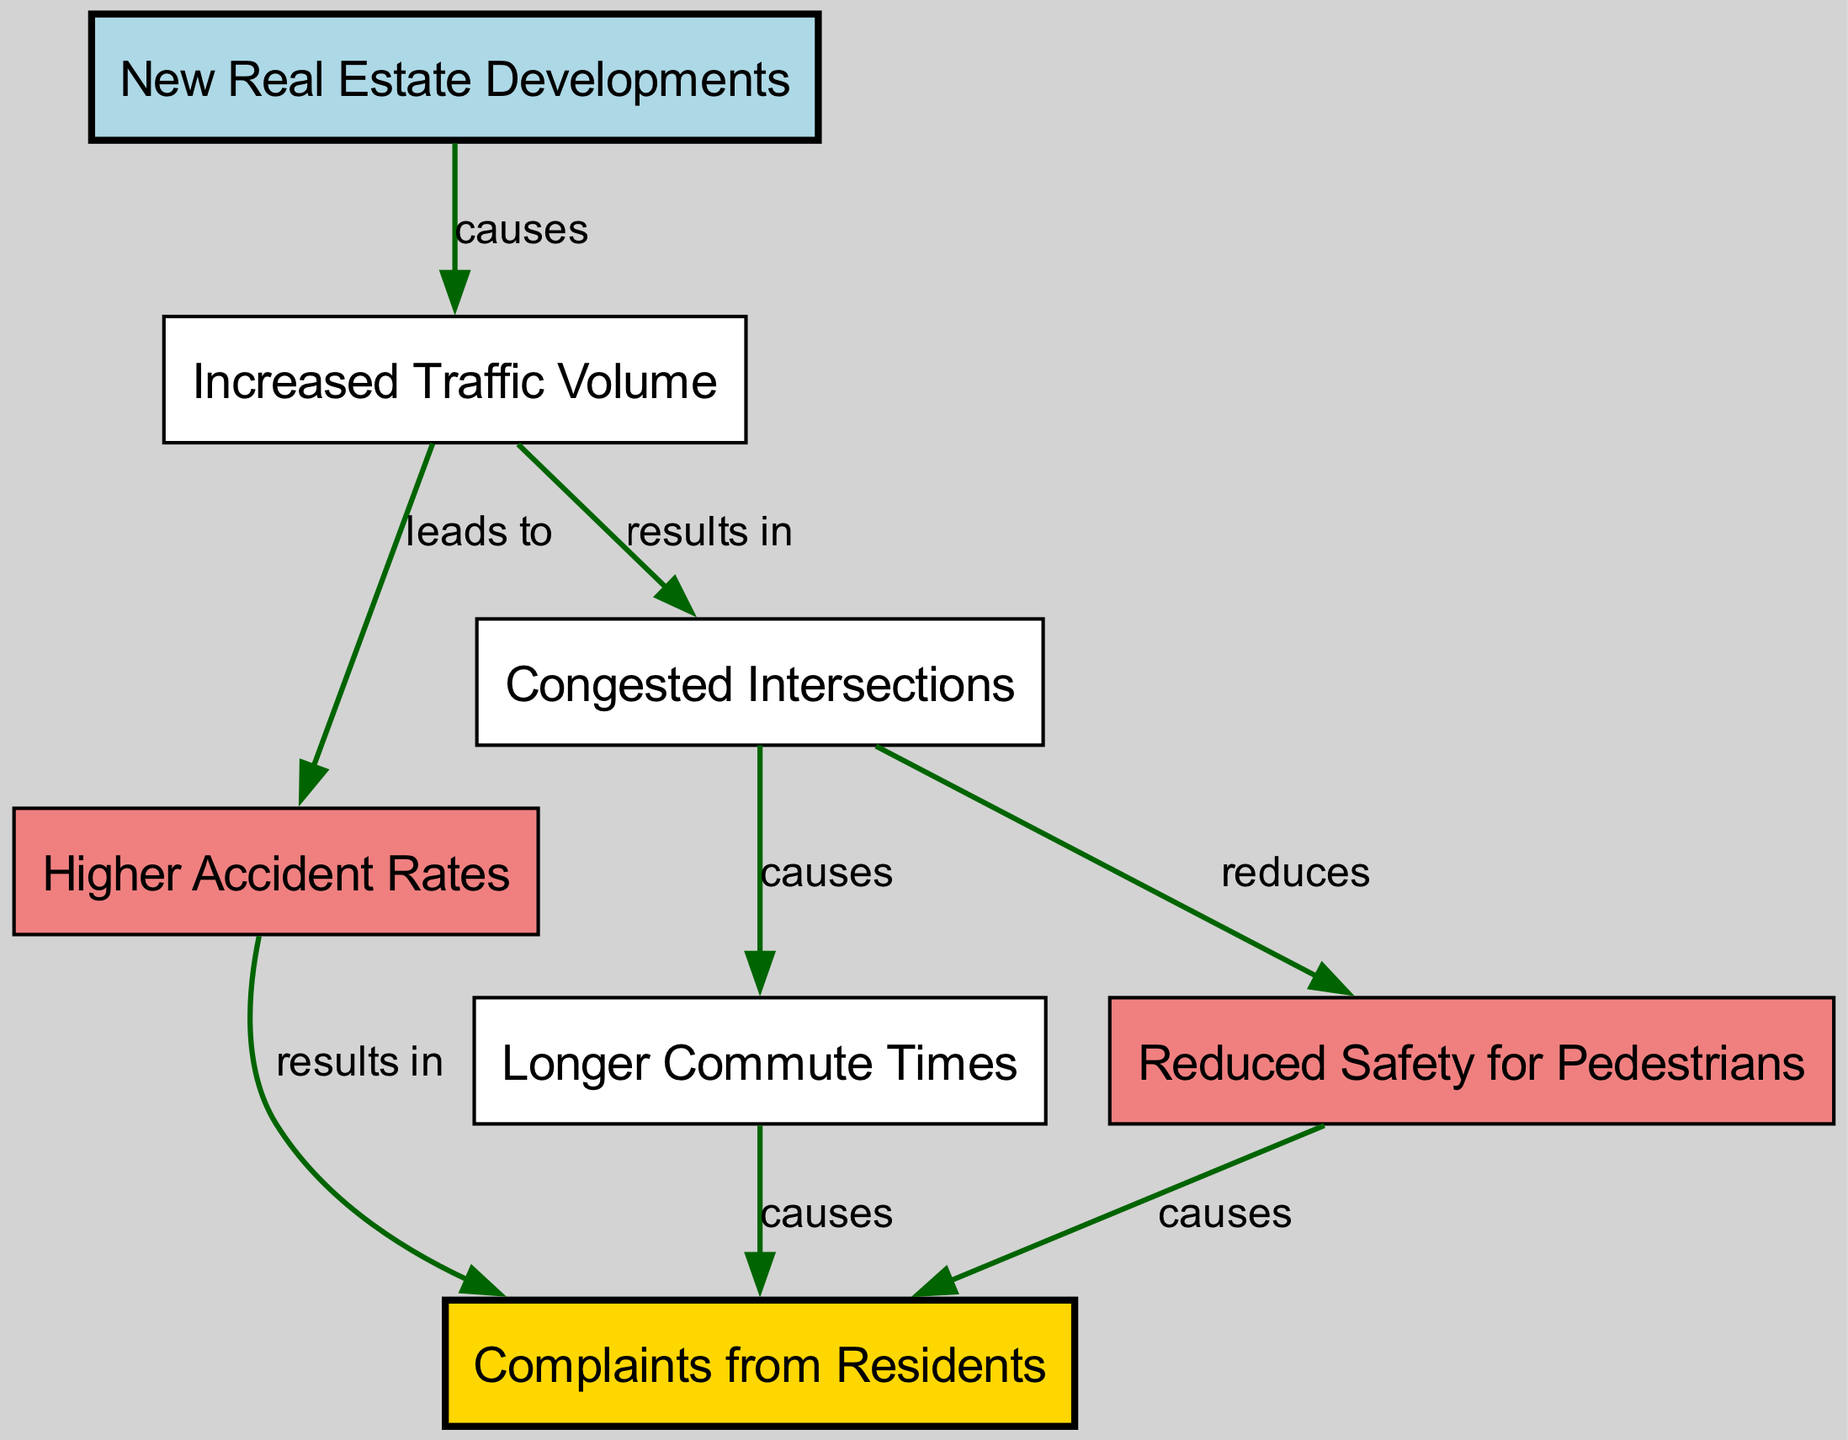What is the initial cause of increased traffic volume? According to the diagram, the node labeled "New Real Estate Developments" is linked to the node "Increased Traffic Volume" with the relationship labeled "causes." Therefore, "New Real Estate Developments" is the direct initial cause of increased traffic volume.
Answer: New Real Estate Developments What do higher accident rates result in? The diagram indicates that the node "Higher Accident Rates" has an outgoing edge to the node "Complaints from Residents" with the relationship labeled "results in." This shows that higher accident rates lead to complaints from residents.
Answer: Complaints from Residents How many nodes are depicted in the diagram? The diagram contains a total of seven nodes, which are "New Real Estate Developments," "Increased Traffic Volume," "Higher Accident Rates," "Congested Intersections," "Longer Commute Times," "Reduced Safety for Pedestrians," and "Complaints from Residents." Therefore, there are seven nodes in total.
Answer: Seven What is the direct consequence of congested intersections? The node "Congested Intersections" is linked to "Longer Commute Times" with the relationship labeled "causes." Hence, the direct consequence of congested intersections is longer commute times.
Answer: Longer Commute Times What effects do higher accident rates have on residents? The diagram illustrates that "Higher Accident Rates" leads to "Complaints from Residents," indicating that higher accident rates generate complaints from residents. Additionally, it also leads to "Reduced Safety for Pedestrians," further affecting residents. Thus, the effects include increased complaints and reduced safety.
Answer: Complaints from Residents, Reduced Safety for Pedestrians What relationship does increased traffic volume have with congested intersections? The diagram shows that increased traffic volume leads to congested intersections, evidenced by the directed edge from the node "Increased Traffic Volume" to "Congested Intersections" labeled "results in." This shows that higher traffic volume is directly related to creating congestion at intersections.
Answer: Congested Intersections How do longer commute times impact residents? The diagram indicates that "Longer Commute Times" has an outgoing edge to "Complaints from Residents" with the relationship labeled "causes." Hence, longer commute times create complaints from the residents regarding their travel experiences.
Answer: Complaints from Residents 